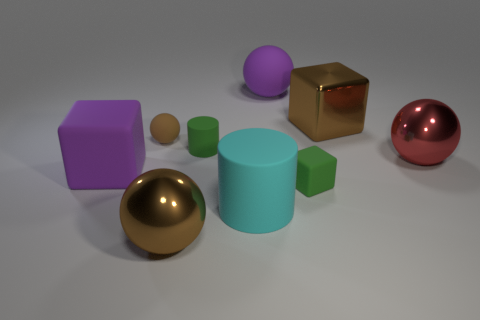Subtract all large purple balls. How many balls are left? 3 Subtract all purple spheres. How many spheres are left? 3 Subtract all gray balls. Subtract all yellow cylinders. How many balls are left? 4 Subtract all cylinders. How many objects are left? 7 Subtract all green cubes. Subtract all red shiny objects. How many objects are left? 7 Add 1 brown metal spheres. How many brown metal spheres are left? 2 Add 5 large brown objects. How many large brown objects exist? 7 Subtract 0 yellow cylinders. How many objects are left? 9 